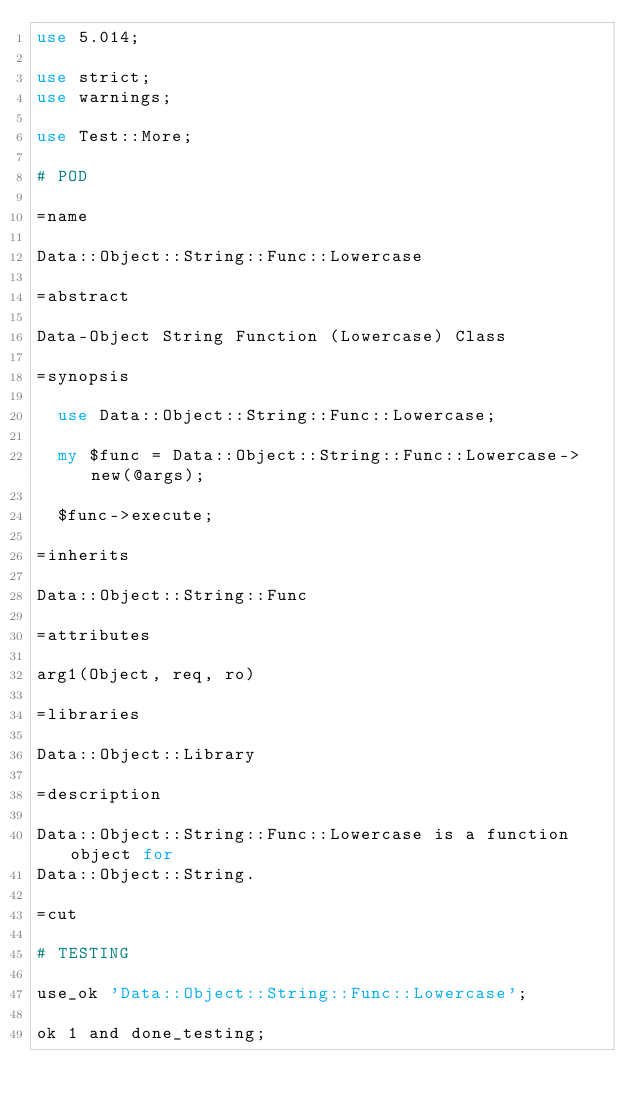Convert code to text. <code><loc_0><loc_0><loc_500><loc_500><_Perl_>use 5.014;

use strict;
use warnings;

use Test::More;

# POD

=name

Data::Object::String::Func::Lowercase

=abstract

Data-Object String Function (Lowercase) Class

=synopsis

  use Data::Object::String::Func::Lowercase;

  my $func = Data::Object::String::Func::Lowercase->new(@args);

  $func->execute;

=inherits

Data::Object::String::Func

=attributes

arg1(Object, req, ro)

=libraries

Data::Object::Library

=description

Data::Object::String::Func::Lowercase is a function object for
Data::Object::String.

=cut

# TESTING

use_ok 'Data::Object::String::Func::Lowercase';

ok 1 and done_testing;
</code> 